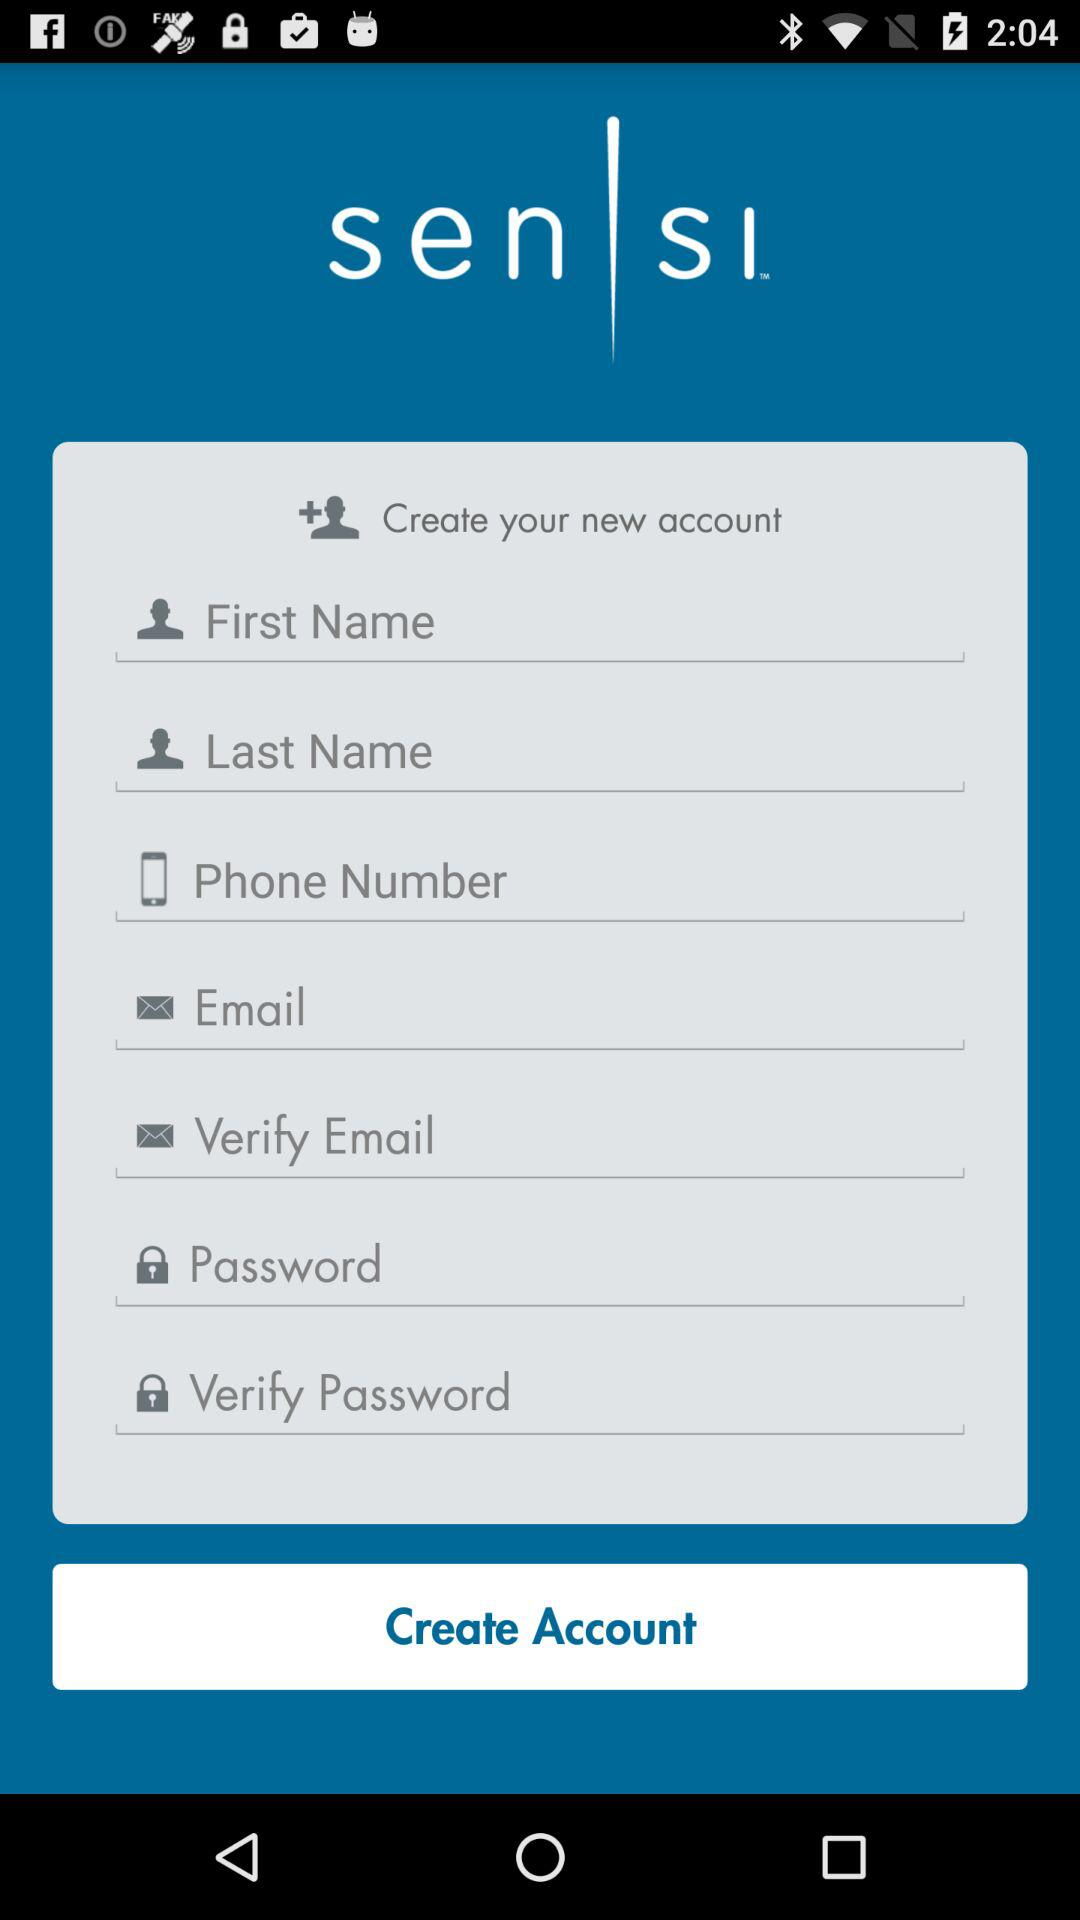What is the name of the application? The name of the application is "Sensi". 